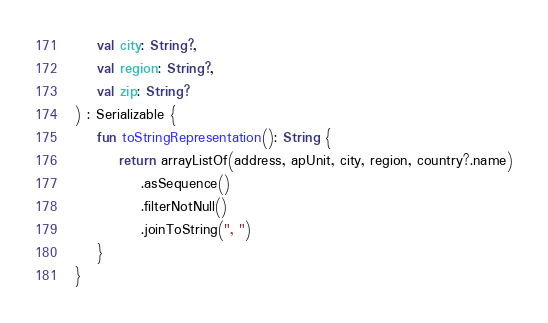Convert code to text. <code><loc_0><loc_0><loc_500><loc_500><_Kotlin_>    val city: String?,
    val region: String?,
    val zip: String?
) : Serializable {
    fun toStringRepresentation(): String {
        return arrayListOf(address, apUnit, city, region, country?.name)
            .asSequence()
            .filterNotNull()
            .joinToString(", ")
    }
}
</code> 